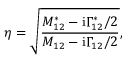Convert formula to latex. <formula><loc_0><loc_0><loc_500><loc_500>\eta = \sqrt { \frac { M _ { 1 2 } ^ { * } - i \Gamma _ { 1 2 } ^ { * } / 2 } { M _ { 1 2 } - i \Gamma _ { 1 2 } / 2 } } ,</formula> 